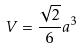Convert formula to latex. <formula><loc_0><loc_0><loc_500><loc_500>V = \frac { \sqrt { 2 } } { 6 } a ^ { 3 }</formula> 